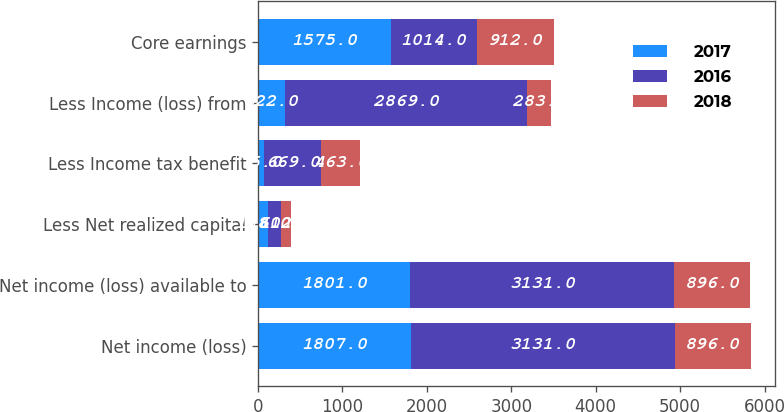Convert chart. <chart><loc_0><loc_0><loc_500><loc_500><stacked_bar_chart><ecel><fcel>Net income (loss)<fcel>Net income (loss) available to<fcel>Less Net realized capital<fcel>Less Income tax benefit<fcel>Less Income (loss) from<fcel>Core earnings<nl><fcel>2017<fcel>1807<fcel>1801<fcel>118<fcel>75<fcel>322<fcel>1575<nl><fcel>2016<fcel>3131<fcel>3131<fcel>160<fcel>669<fcel>2869<fcel>1014<nl><fcel>2018<fcel>896<fcel>896<fcel>112<fcel>463<fcel>283<fcel>912<nl></chart> 